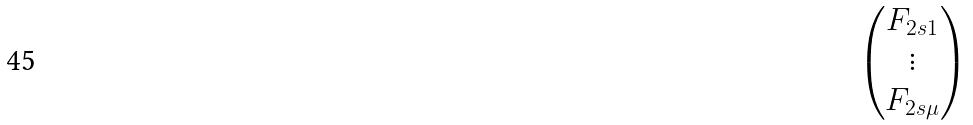Convert formula to latex. <formula><loc_0><loc_0><loc_500><loc_500>\begin{pmatrix} F _ { 2 s 1 } \\ \vdots \\ F _ { 2 s \mu } \end{pmatrix}</formula> 